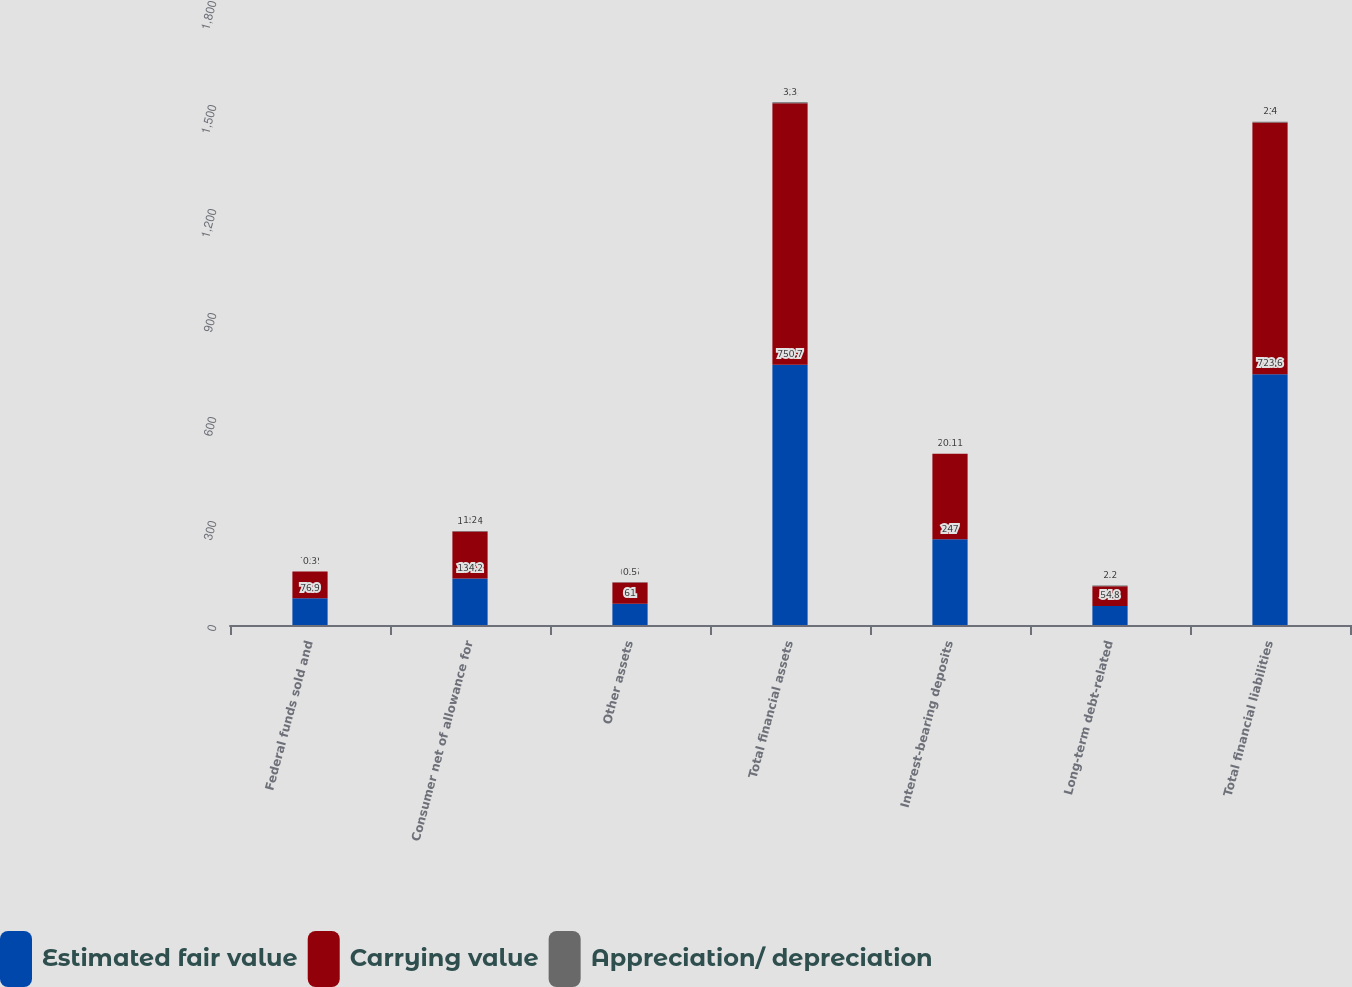<chart> <loc_0><loc_0><loc_500><loc_500><stacked_bar_chart><ecel><fcel>Federal funds sold and<fcel>Consumer net of allowance for<fcel>Other assets<fcel>Total financial assets<fcel>Interest-bearing deposits<fcel>Long-term debt-related<fcel>Total financial liabilities<nl><fcel>Estimated fair value<fcel>76.9<fcel>134.2<fcel>61<fcel>750.7<fcel>247<fcel>54.8<fcel>723.6<nl><fcel>Carrying value<fcel>77.2<fcel>135.4<fcel>61.5<fcel>754<fcel>247.1<fcel>57<fcel>726<nl><fcel>Appreciation/ depreciation<fcel>0.3<fcel>1.2<fcel>0.5<fcel>3.3<fcel>0.1<fcel>2.2<fcel>2.4<nl></chart> 